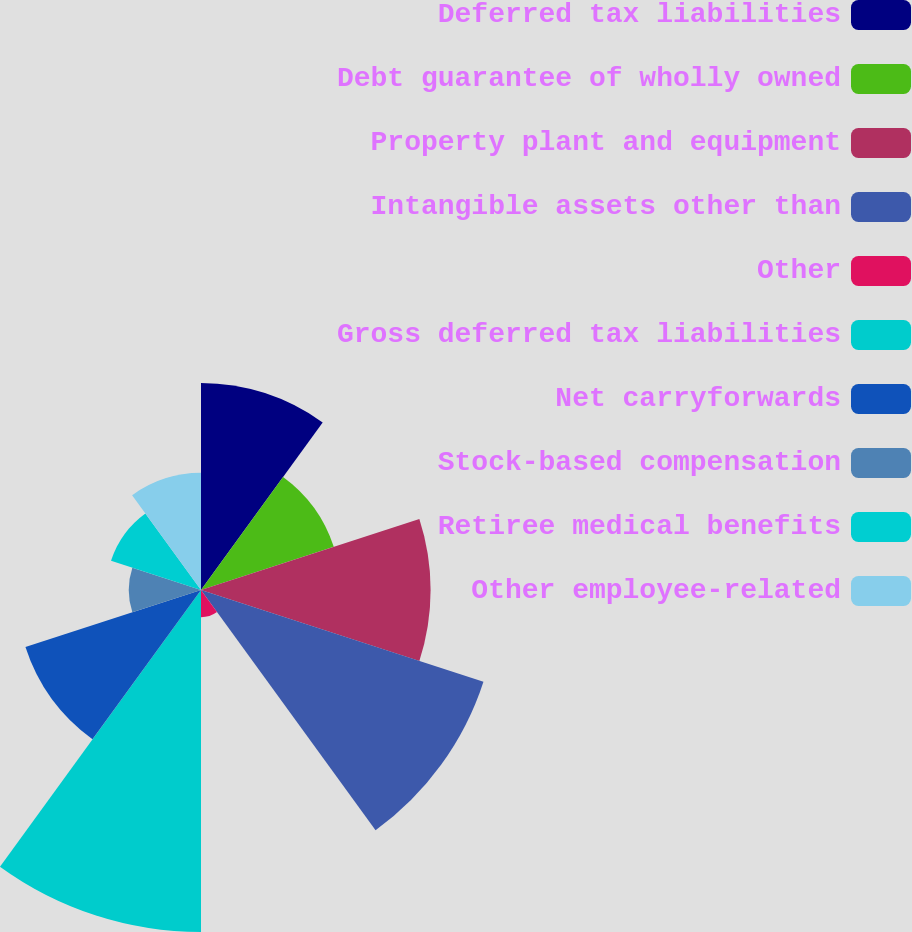<chart> <loc_0><loc_0><loc_500><loc_500><pie_chart><fcel>Deferred tax liabilities<fcel>Debt guarantee of wholly owned<fcel>Property plant and equipment<fcel>Intangible assets other than<fcel>Other<fcel>Gross deferred tax liabilities<fcel>Net carryforwards<fcel>Stock-based compensation<fcel>Retiree medical benefits<fcel>Other employee-related<nl><fcel>12.1%<fcel>8.16%<fcel>13.42%<fcel>17.36%<fcel>1.59%<fcel>19.99%<fcel>10.79%<fcel>4.22%<fcel>5.53%<fcel>6.85%<nl></chart> 